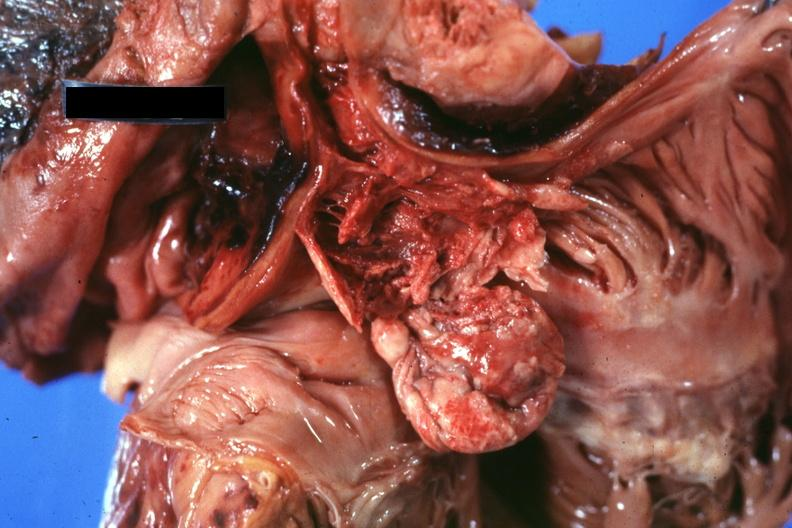does this image show opened right atrium and superior vena cava showing thrombus and tumor occlusion of cava extending into atrium?
Answer the question using a single word or phrase. Yes 